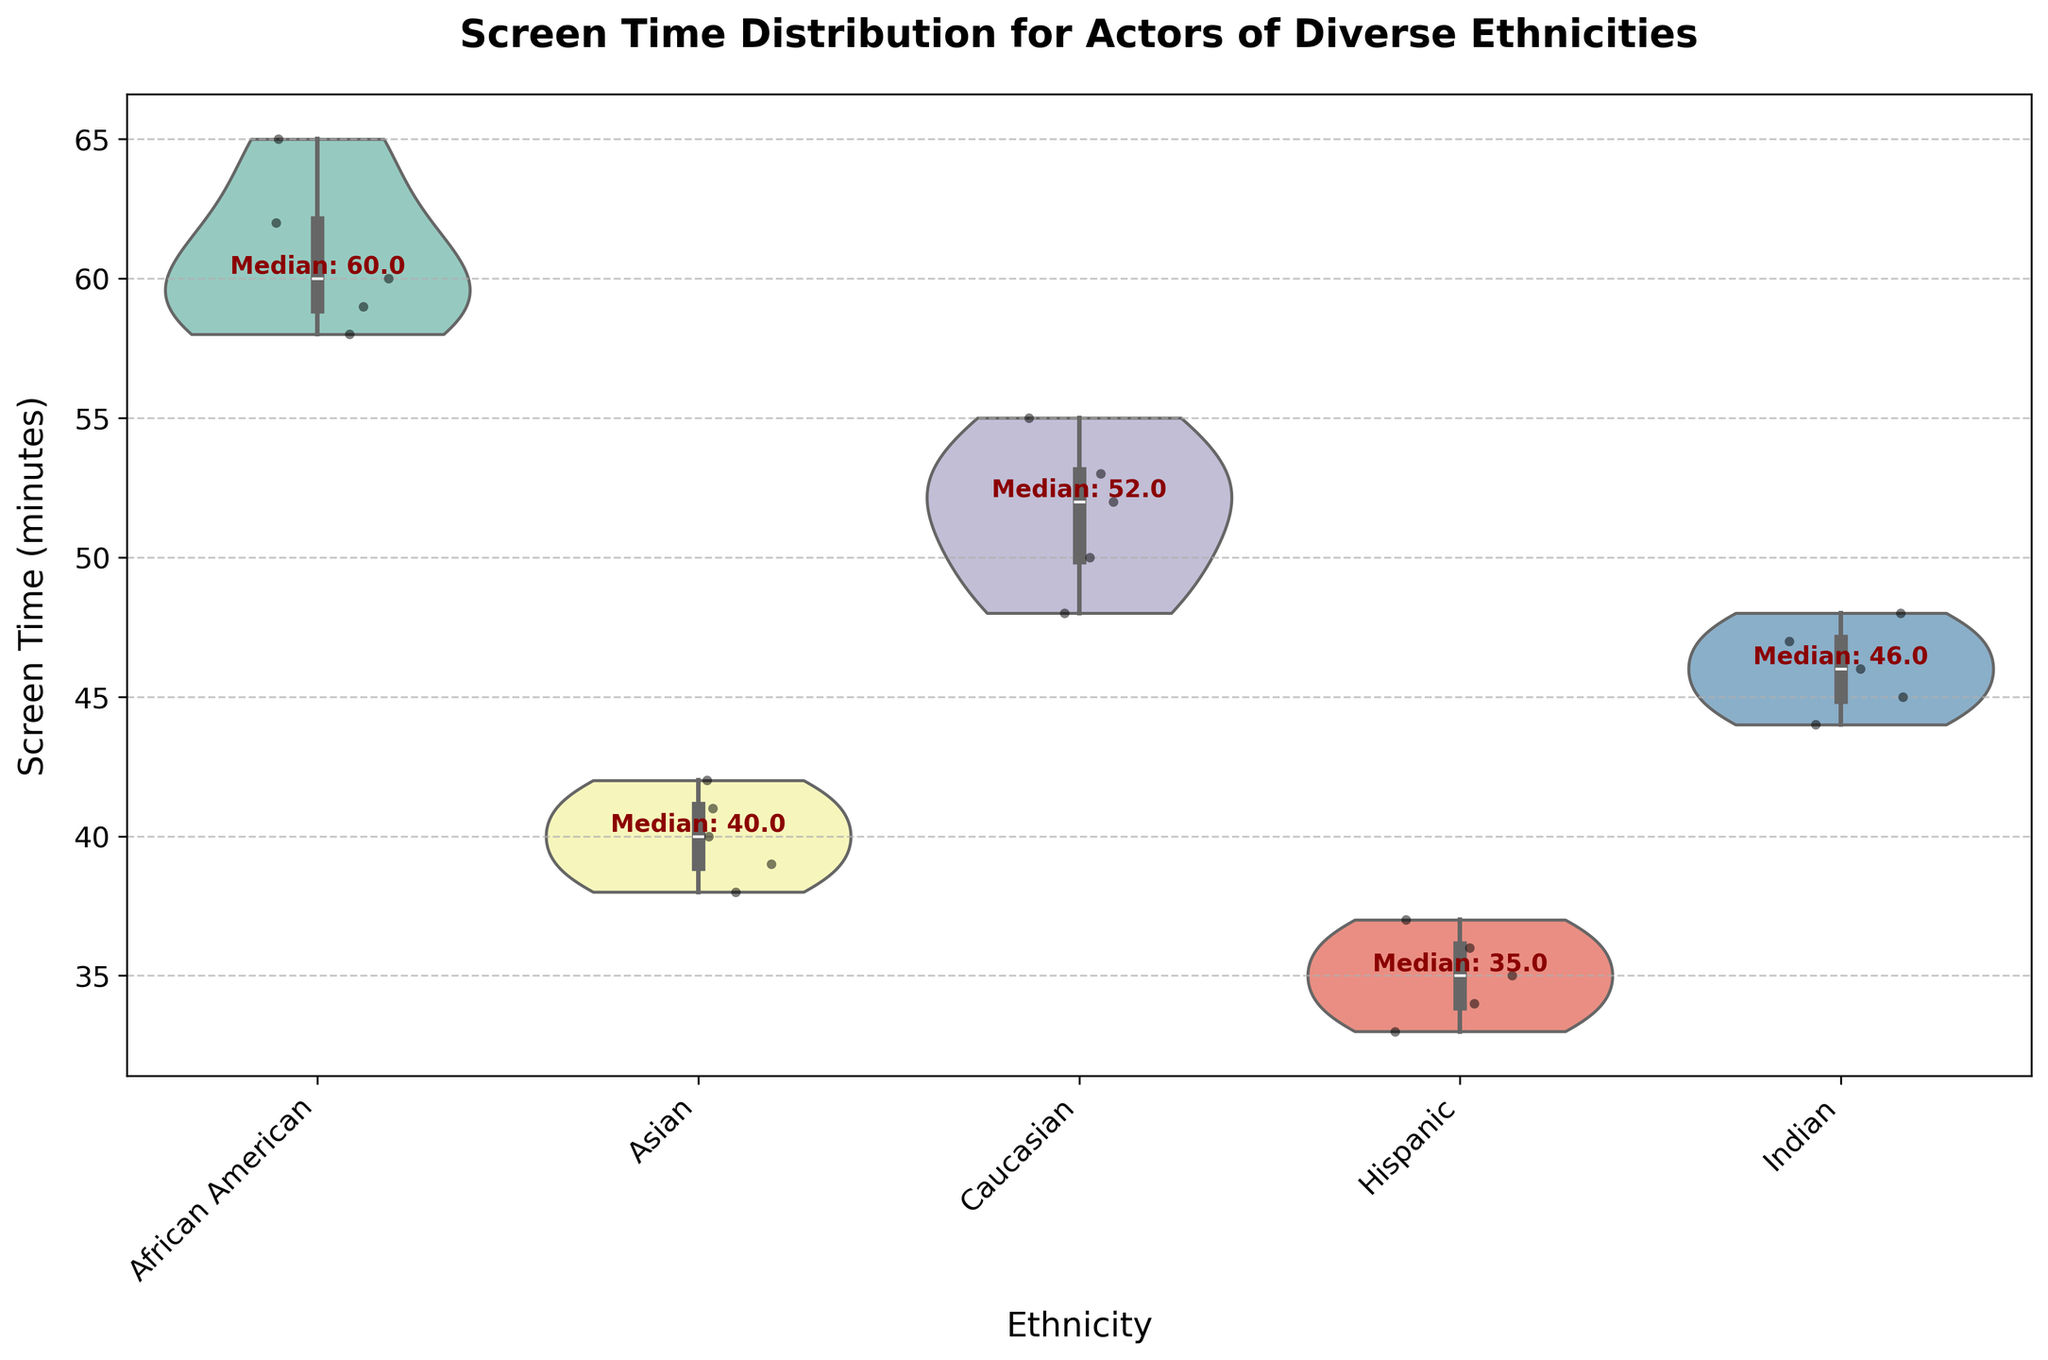What's the title of the plot? The title can be found at the top of the figure. It reads: "Screen Time Distribution for Actors of Diverse Ethnicities".
Answer: Screen Time Distribution for Actors of Diverse Ethnicities Which ethnicity has the highest median screen time? Look at the text annotations next to each violin plot. The highest median value indicated is for African American actors.
Answer: African American What is the median screen time for Hispanic actors? Look at the text annotation next to the violin plot for Hispanic actors. The median value written is 35.
Answer: 35 How do the median screen times for African American and Asian actors compare? Compare the text annotations for both groups. African American actors have a median of 59, while Asian actors have a median of 40. Thus, African American actors have a higher median screen time than Asian actors.
Answer: African American actors have a higher median screen time What pattern do the violin plots show about the spread of screen time across different ethnicities? The violin plots illustrate the distribution of screen time. African American actors have a more concentrated spread around their median, while other ethnic groups show varied distributions.
Answer: Different spreads for each ethnicity Are there any outliers in the screen time data? The presence of any outliers would be indicated by isolated points outside the main body of the violin plots. In this case, there are no significant outliers visible.
Answer: No Which ethnicity has the widest range of screen times? Examine the width and height of each violin plot. African American actors have the widest range, stretching from about 58 to 65 minutes.
Answer: African American Based on the figure, which two ethnicities have the closest median screen times? Compare the text annotations next to the violin plots for each ethnic group. Asian (40) and Indian (46) actors have the closest median screen times.
Answer: Asian and Indian What does the 'inner' boxplot in the violin plot represent? The 'inner' box within each violin plot represents the interquartile range (IQR), which shows the spread of the middle 50% of the data points.
Answer: Interquartile range Which film is associated with the Hispanic ethnicity in the plot? Refer to the provided data to find that the film associated with Hispanic ethnicity is "Coco".
Answer: Coco 